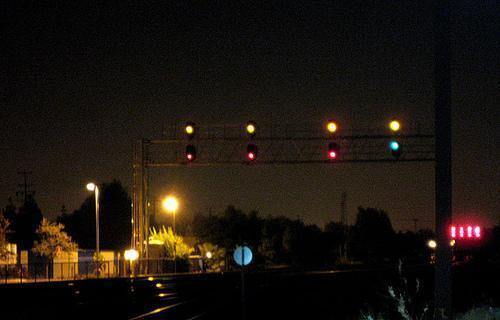How many yellow lights?
Give a very brief answer. 4. How many people are wearing brown shirt?
Give a very brief answer. 0. 